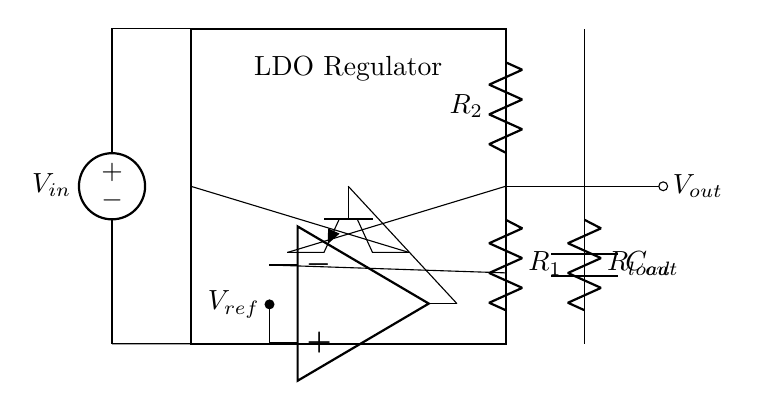What is the main function of the LDO regulator? The LDO regulator maintains a constant output voltage even when the input voltage varies, ensuring that the connected devices receive the required voltage for operation.
Answer: Maintain constant voltage What are the components used for feedback in this circuit? The feedback components in the circuit are R1 and R2, which are resistors connected to the output and the reference voltage input, forming a voltage divider to compare the output voltage with the reference voltage.
Answer: R1 and R2 What is the role of the error amplifier in this circuit? The error amplifier compares the output voltage to the reference voltage and adjusts the control signal to the pass transistor to ensure the output voltage remains stable, correcting any deviations from the desired voltage.
Answer: Regulation of output voltage What type of transistor is used as the pass element in this LDO circuit? An NPN transistor, which is a type of bipolar junction transistor, is used as the pass transistor designed to control the current flow based on the feedback from the error amplifier.
Answer: NPN How does the output capacitor influence the LDO performance? The output capacitor, Cout, stabilizes the output voltage during transient loads, reduces output voltage ripple, and improves transient response, ensuring smooth supply to the load connected at Vout.
Answer: Stabilization of output voltage What is the purpose of the reference voltage in this circuit? The reference voltage, Vref, provides a stable voltage level that the error amplifier uses to compare with the actual output voltage, guiding the regulator's adjustments to maintain the desired output.
Answer: Provide stable voltage 